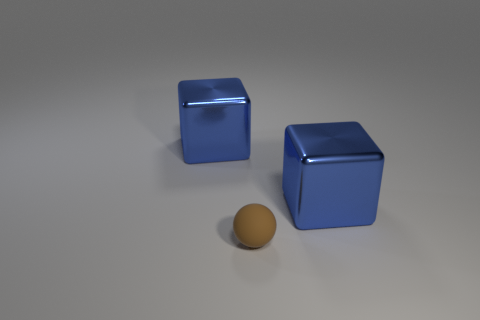Add 3 big blue metallic blocks. How many objects exist? 6 Subtract all spheres. How many objects are left? 2 Subtract 0 yellow cubes. How many objects are left? 3 Subtract all brown balls. Subtract all metal blocks. How many objects are left? 0 Add 3 matte objects. How many matte objects are left? 4 Add 3 small gray matte cubes. How many small gray matte cubes exist? 3 